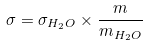<formula> <loc_0><loc_0><loc_500><loc_500>\sigma = \sigma _ { H _ { 2 } O } \times \frac { m } { m _ { H _ { 2 } O } }</formula> 